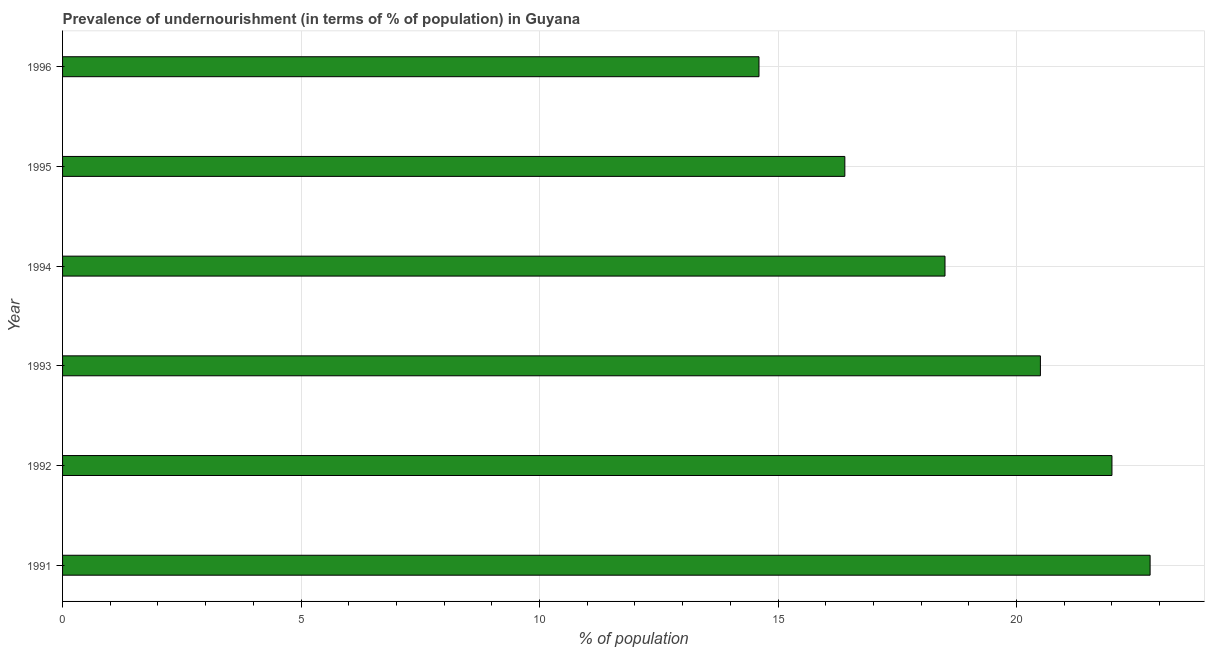What is the title of the graph?
Your answer should be very brief. Prevalence of undernourishment (in terms of % of population) in Guyana. What is the label or title of the X-axis?
Your answer should be very brief. % of population. What is the label or title of the Y-axis?
Ensure brevity in your answer.  Year. Across all years, what is the maximum percentage of undernourished population?
Your response must be concise. 22.8. Across all years, what is the minimum percentage of undernourished population?
Make the answer very short. 14.6. What is the sum of the percentage of undernourished population?
Your response must be concise. 114.8. What is the average percentage of undernourished population per year?
Your response must be concise. 19.13. Do a majority of the years between 1992 and 1996 (inclusive) have percentage of undernourished population greater than 18 %?
Your answer should be compact. Yes. What is the ratio of the percentage of undernourished population in 1994 to that in 1996?
Provide a short and direct response. 1.27. Is the difference between the percentage of undernourished population in 1992 and 1994 greater than the difference between any two years?
Offer a very short reply. No. What is the difference between the highest and the second highest percentage of undernourished population?
Provide a short and direct response. 0.8. Is the sum of the percentage of undernourished population in 1993 and 1995 greater than the maximum percentage of undernourished population across all years?
Provide a short and direct response. Yes. In how many years, is the percentage of undernourished population greater than the average percentage of undernourished population taken over all years?
Provide a succinct answer. 3. How many bars are there?
Keep it short and to the point. 6. Are all the bars in the graph horizontal?
Keep it short and to the point. Yes. How many years are there in the graph?
Provide a succinct answer. 6. Are the values on the major ticks of X-axis written in scientific E-notation?
Offer a very short reply. No. What is the % of population of 1991?
Keep it short and to the point. 22.8. What is the % of population of 1993?
Ensure brevity in your answer.  20.5. What is the % of population in 1994?
Give a very brief answer. 18.5. What is the % of population of 1996?
Your answer should be very brief. 14.6. What is the difference between the % of population in 1991 and 1992?
Your response must be concise. 0.8. What is the difference between the % of population in 1991 and 1993?
Your response must be concise. 2.3. What is the difference between the % of population in 1991 and 1994?
Your answer should be compact. 4.3. What is the difference between the % of population in 1991 and 1995?
Keep it short and to the point. 6.4. What is the difference between the % of population in 1991 and 1996?
Ensure brevity in your answer.  8.2. What is the difference between the % of population in 1992 and 1994?
Provide a short and direct response. 3.5. What is the difference between the % of population in 1992 and 1995?
Make the answer very short. 5.6. What is the difference between the % of population in 1993 and 1994?
Your response must be concise. 2. What is the difference between the % of population in 1995 and 1996?
Offer a very short reply. 1.8. What is the ratio of the % of population in 1991 to that in 1992?
Offer a terse response. 1.04. What is the ratio of the % of population in 1991 to that in 1993?
Give a very brief answer. 1.11. What is the ratio of the % of population in 1991 to that in 1994?
Your response must be concise. 1.23. What is the ratio of the % of population in 1991 to that in 1995?
Provide a short and direct response. 1.39. What is the ratio of the % of population in 1991 to that in 1996?
Offer a very short reply. 1.56. What is the ratio of the % of population in 1992 to that in 1993?
Give a very brief answer. 1.07. What is the ratio of the % of population in 1992 to that in 1994?
Your answer should be compact. 1.19. What is the ratio of the % of population in 1992 to that in 1995?
Provide a short and direct response. 1.34. What is the ratio of the % of population in 1992 to that in 1996?
Ensure brevity in your answer.  1.51. What is the ratio of the % of population in 1993 to that in 1994?
Make the answer very short. 1.11. What is the ratio of the % of population in 1993 to that in 1996?
Make the answer very short. 1.4. What is the ratio of the % of population in 1994 to that in 1995?
Provide a succinct answer. 1.13. What is the ratio of the % of population in 1994 to that in 1996?
Provide a succinct answer. 1.27. What is the ratio of the % of population in 1995 to that in 1996?
Offer a very short reply. 1.12. 